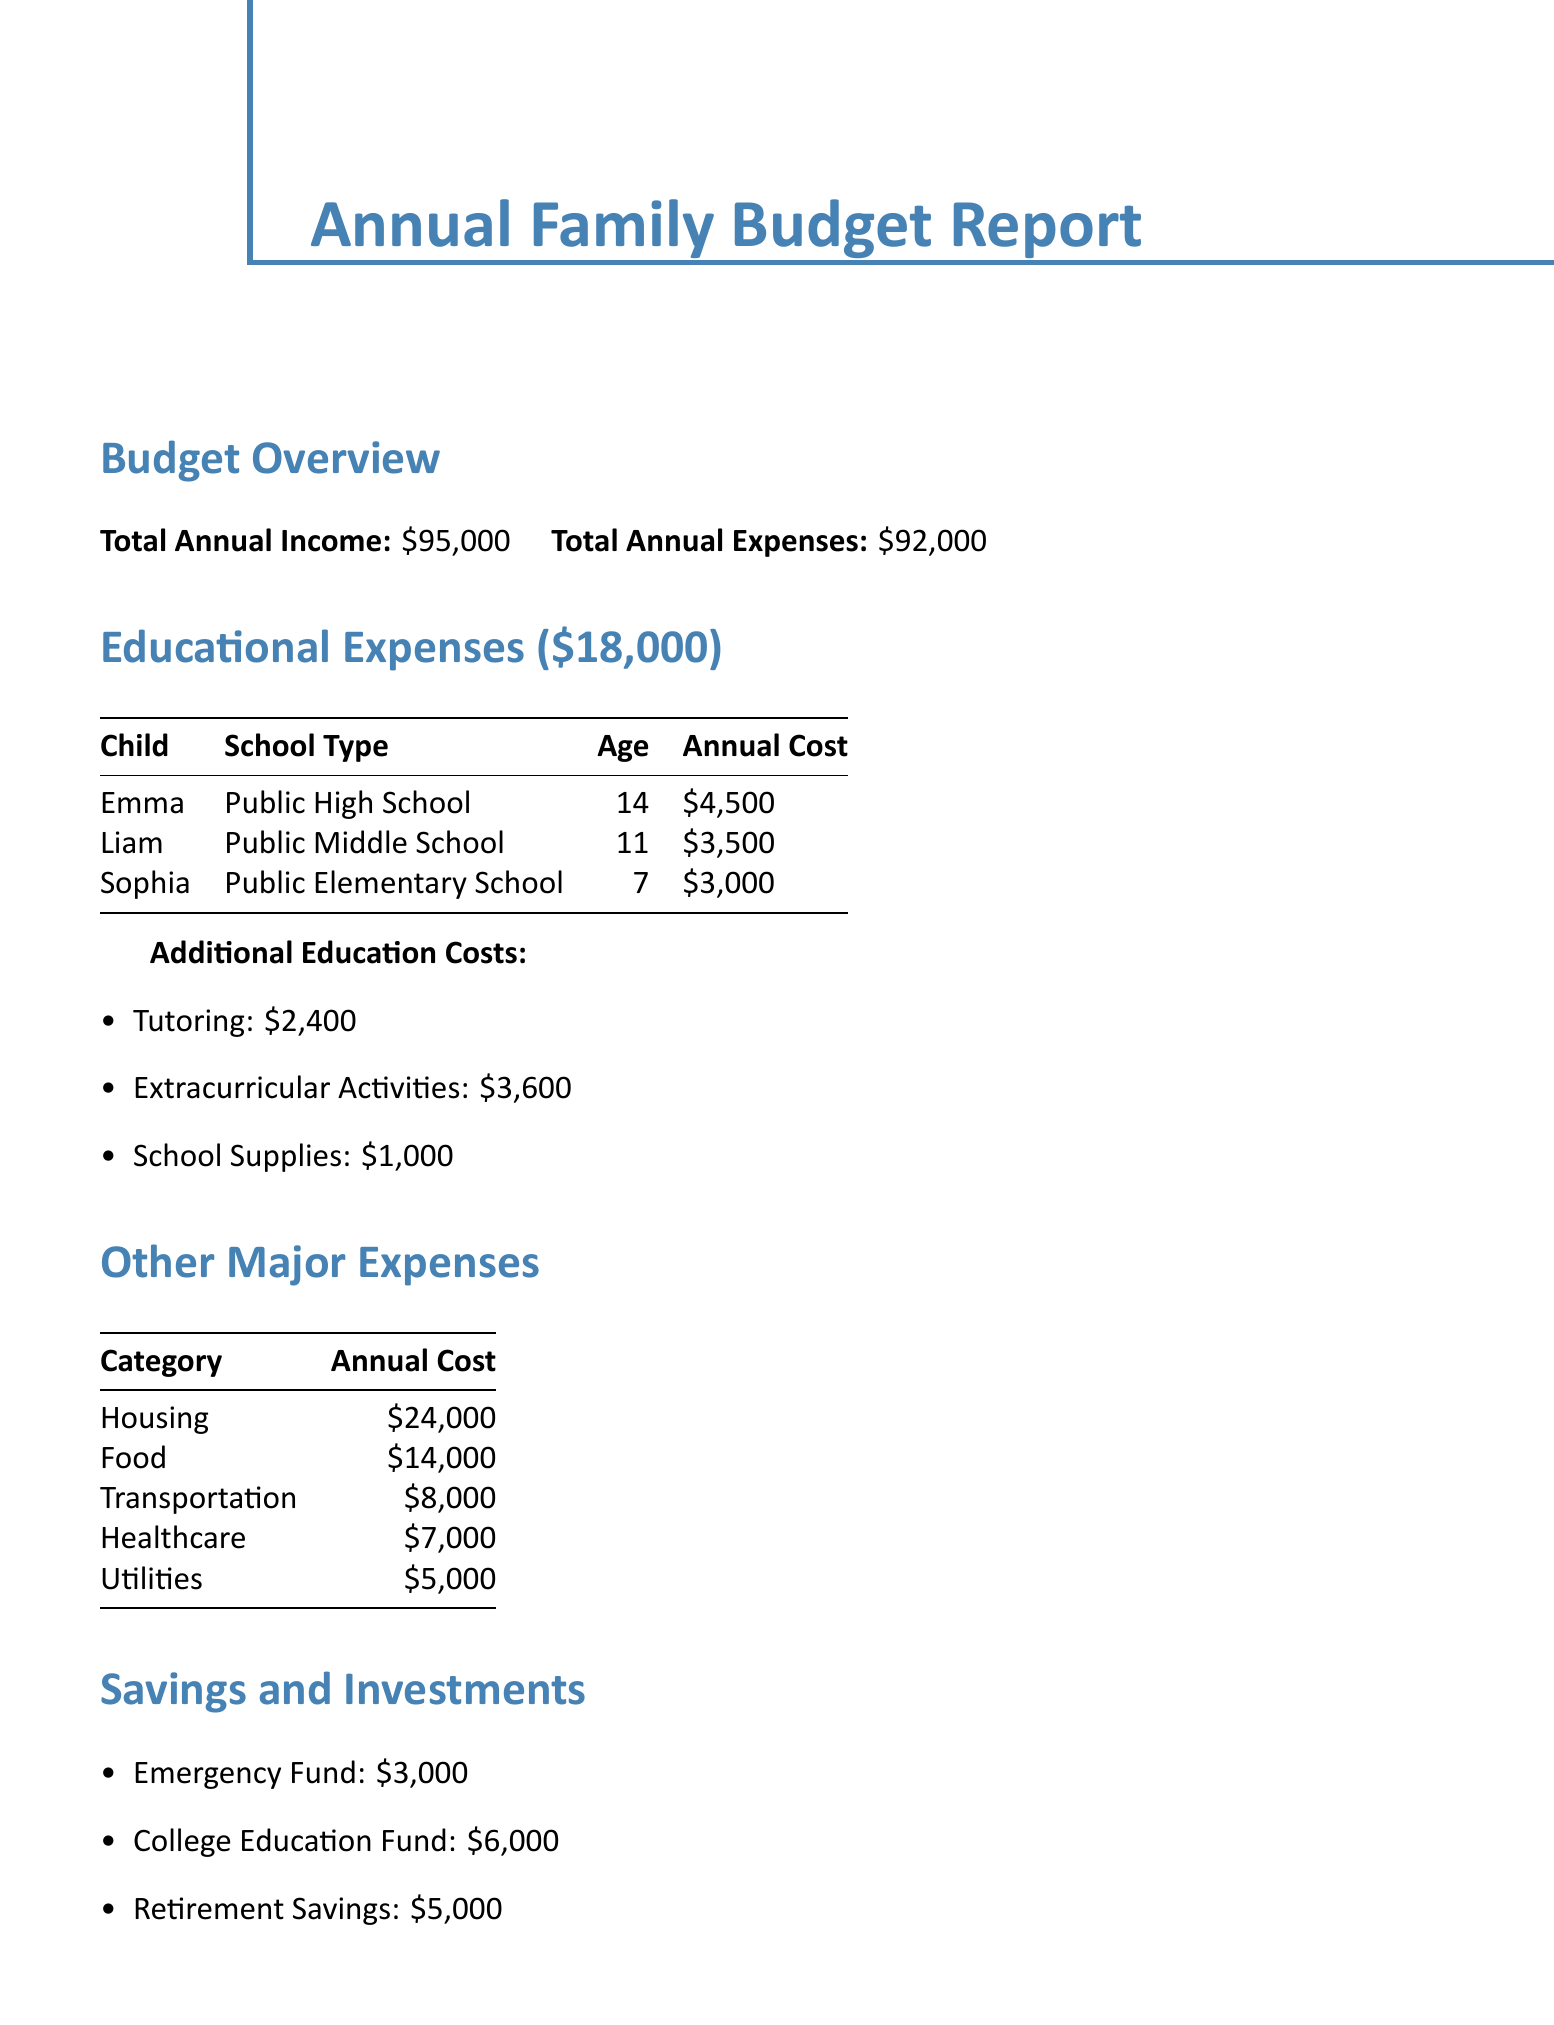what is the total annual income? The total annual income is stated in the budget overview section of the document as $95,000.
Answer: $95,000 how much is spent on Emma's education? The document indicates Emma's annual education cost is listed in the educational expenses section as $4,500.
Answer: $4,500 what percentage of the total annual expenses is allocated to educational costs? The educational expenses total $18,000, which is a fraction of the total annual expenses of $92,000; hence, the percentage is calculated as (18,000 / 92,000) * 100.
Answer: 19.57% how much is allocated for the college education fund? The savings and investments section states that the college education fund is allocated $6,000.
Answer: $6,000 which organization is supported by the women's rights donation? The document lists several organizations supported by the annual donation, including the National Women's Law Center.
Answer: National Women's Law Center what are the total additional educational costs? The total additional education costs are the sum of tutoring, extracurricular activities, and school supplies, which is $2,400 + $3,600 + $1,000 = $7,000.
Answer: $7,000 how old is Sophia? Sophia's age is explicitly stated in the breakdown by child section of the document as 7 years old.
Answer: 7 what is the annual cost for extracurricular activities? The document specifies that the annual cost for extracurricular activities is $3,600.
Answer: $3,600 